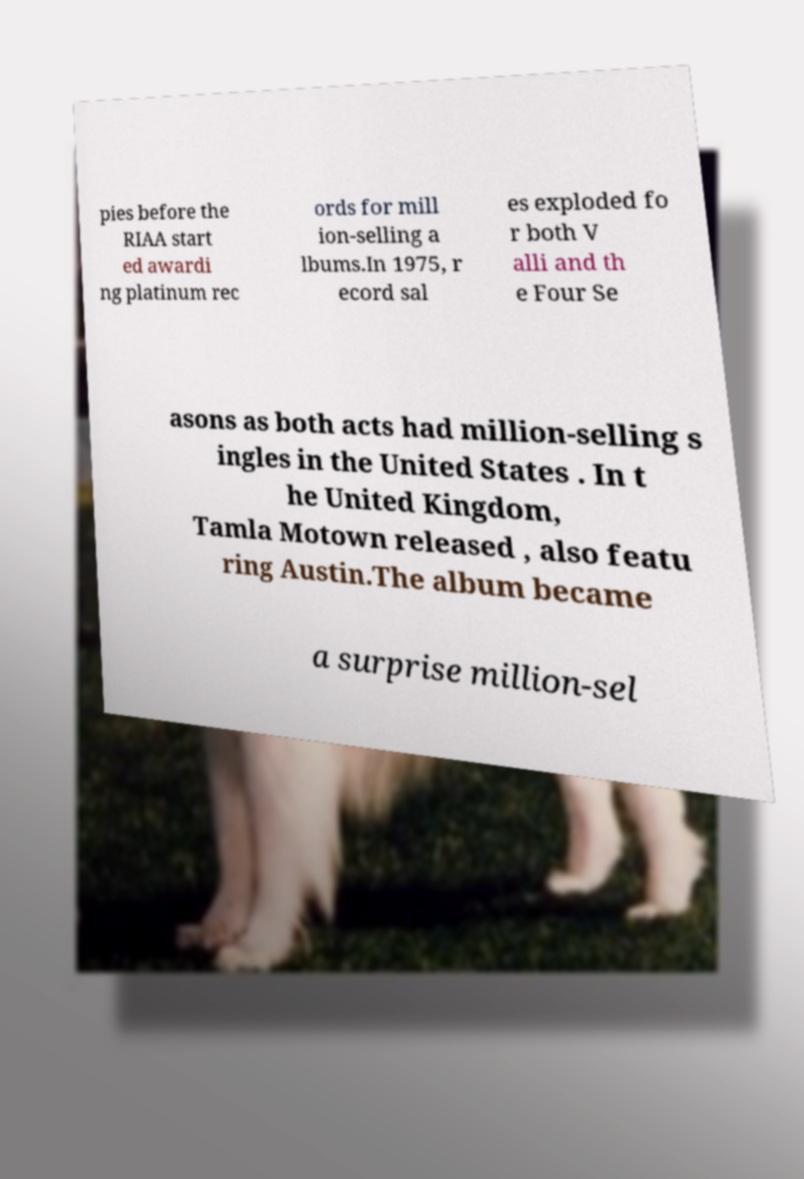There's text embedded in this image that I need extracted. Can you transcribe it verbatim? pies before the RIAA start ed awardi ng platinum rec ords for mill ion-selling a lbums.In 1975, r ecord sal es exploded fo r both V alli and th e Four Se asons as both acts had million-selling s ingles in the United States . In t he United Kingdom, Tamla Motown released , also featu ring Austin.The album became a surprise million-sel 